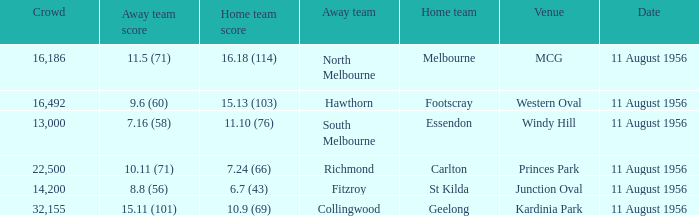At western oval, which team played as the home team? Footscray. 